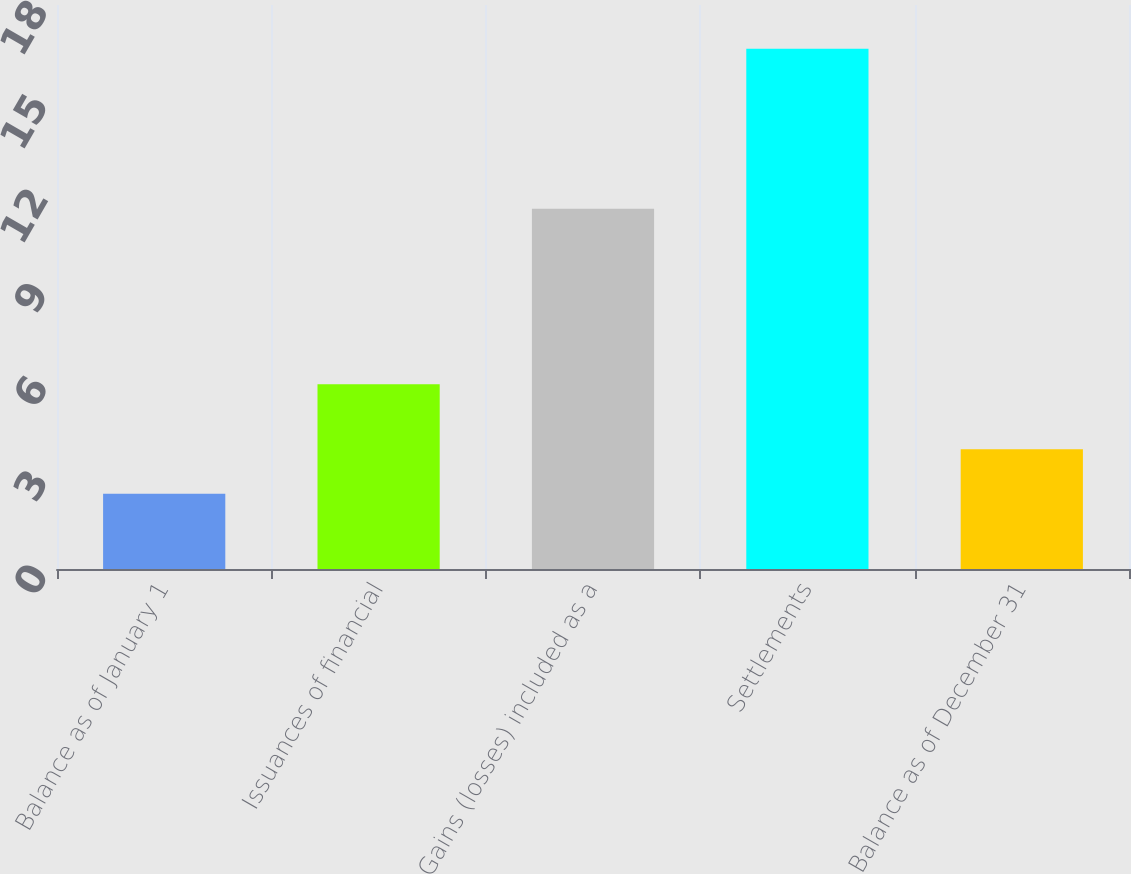Convert chart. <chart><loc_0><loc_0><loc_500><loc_500><bar_chart><fcel>Balance as of January 1<fcel>Issuances of financial<fcel>Gains (losses) included as a<fcel>Settlements<fcel>Balance as of December 31<nl><fcel>2.4<fcel>5.9<fcel>11.5<fcel>16.6<fcel>3.82<nl></chart> 